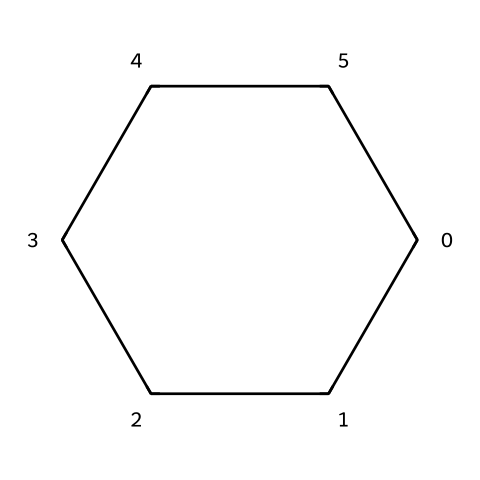What is the chemical name of this structure? The SMILES representation "C1CCCCC1" corresponds to a cyclohexane structure, which is a six-membered carbon ring with single bonds.
Answer: cyclohexane How many carbon atoms are present in this molecule? Looking at the SMILES representation, there are 6 "C" characters, indicating 6 carbon atoms in the structure.
Answer: 6 What type of bonding is present in cyclohexane? The structure comprised only of single bonds between carbon atoms indicates the presence of sigma bonds. There are no double or triple bonds shown in the SMILES.
Answer: single bonds What is the degree of saturation of cyclohexane? Cyclohexane is fully saturated as it contains only single bonds and no functional groups; this means the degree of saturation is maximal for its number of carbon atoms.
Answer: saturated What is the hybridization of the carbon atoms in cyclohexane? Each carbon atom in cyclohexane is bonded to two other carbon atoms and two hydrogen atoms, which aligns with an sp3 hybridization, typical for carbon in single-bonded structures.
Answer: sp3 Can cyclohexane exhibit cis-trans isomerism? Cyclohexane does not show cis-trans isomerism because all carbon atoms in the ring are connected by single bonds, preventing fixed geometries to create isomers.
Answer: no 